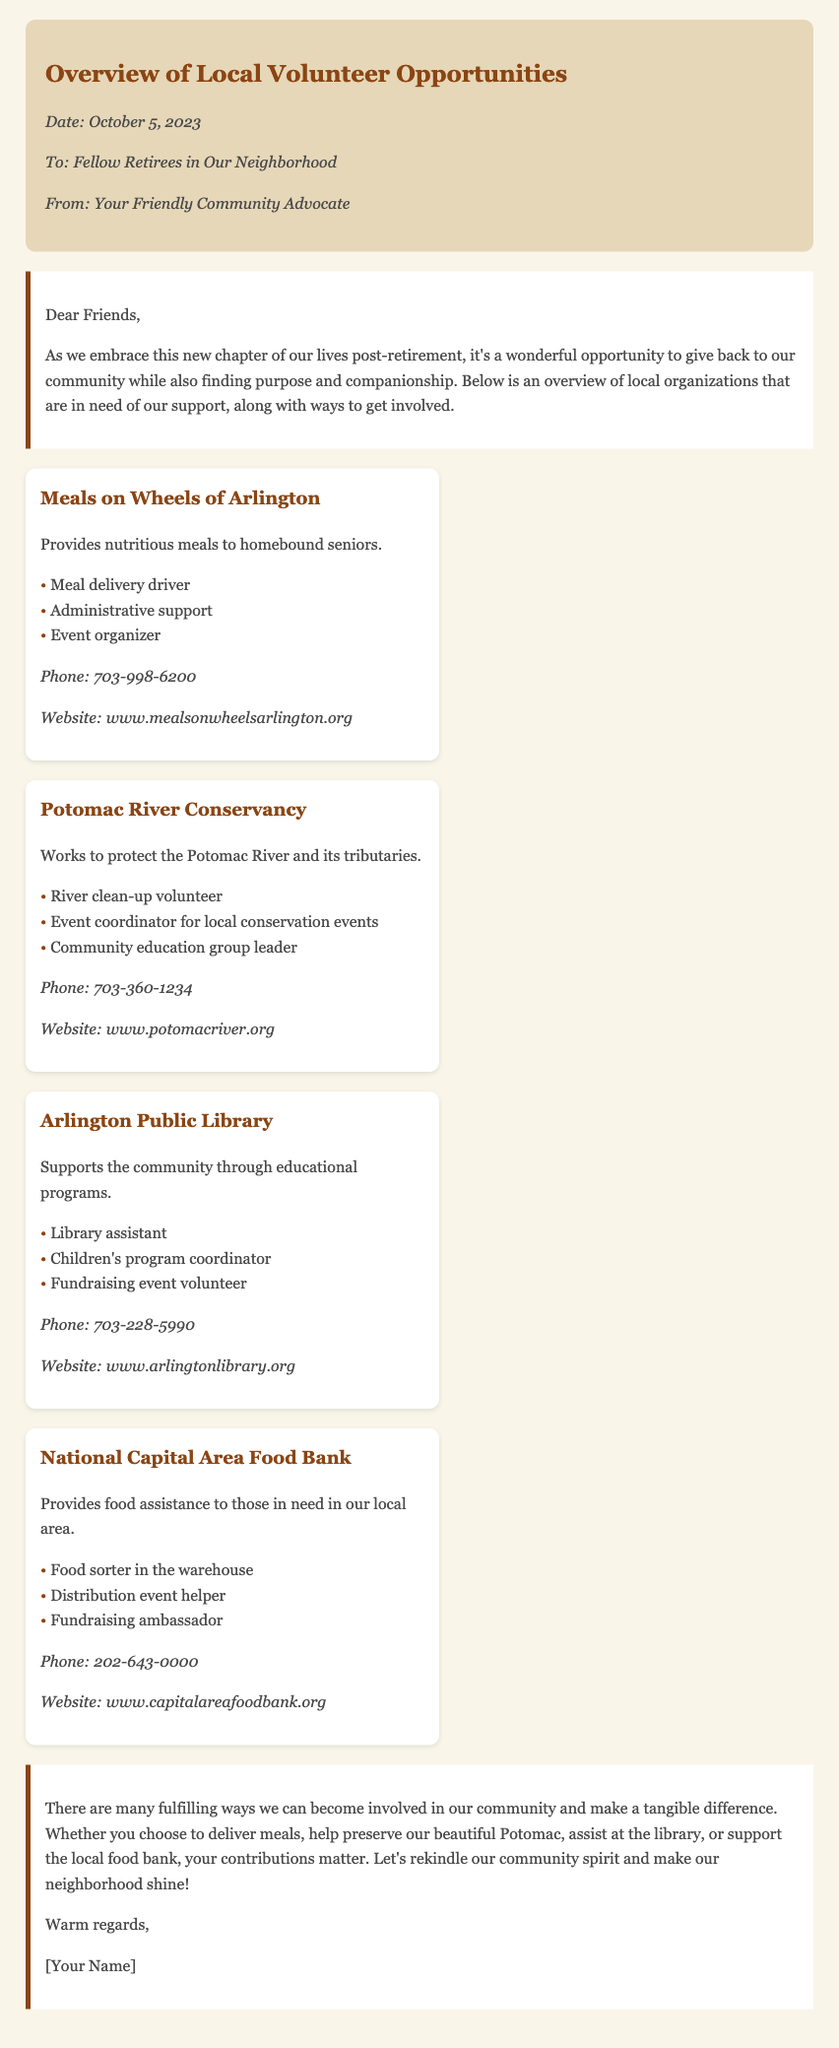what is the date of the memo? The date is mentioned at the beginning of the document, indicating when it was written.
Answer: October 5, 2023 who is the intended audience of the memo? The memo specifies that it is directed towards a particular group of people in the community.
Answer: Fellow Retirees in Our Neighborhood what organization provides meals to homebound seniors? This information can be found under the opportunities section, specifically detailing what each organization does.
Answer: Meals on Wheels of Arlington how many roles are listed for the Arlington Public Library? The number of roles is determined by counting the entries under the Arlington Public Library section.
Answer: Three what is one way to get involved with the Potomac River Conservancy? The methods of involvement are listed as various roles in the organization, which indicate how people can contribute.
Answer: River clean-up volunteer what is the phone number for the National Capital Area Food Bank? The contact section for each organization provides their phone numbers for inquiries.
Answer: 202-643-0000 which organization is focused on educational programs? The function of each organization is described, indicating their areas of focus.
Answer: Arlington Public Library what role does a food sorter perform at the National Capital Area Food Bank? This role is among the listed responsibilities for volunteers at the food bank.
Answer: Food sorter in the warehouse what kind of events does the Potomac River Conservancy coordinate? The document provides information on the types of events that volunteers can help with, indicating their engagement with the community.
Answer: Local conservation events 